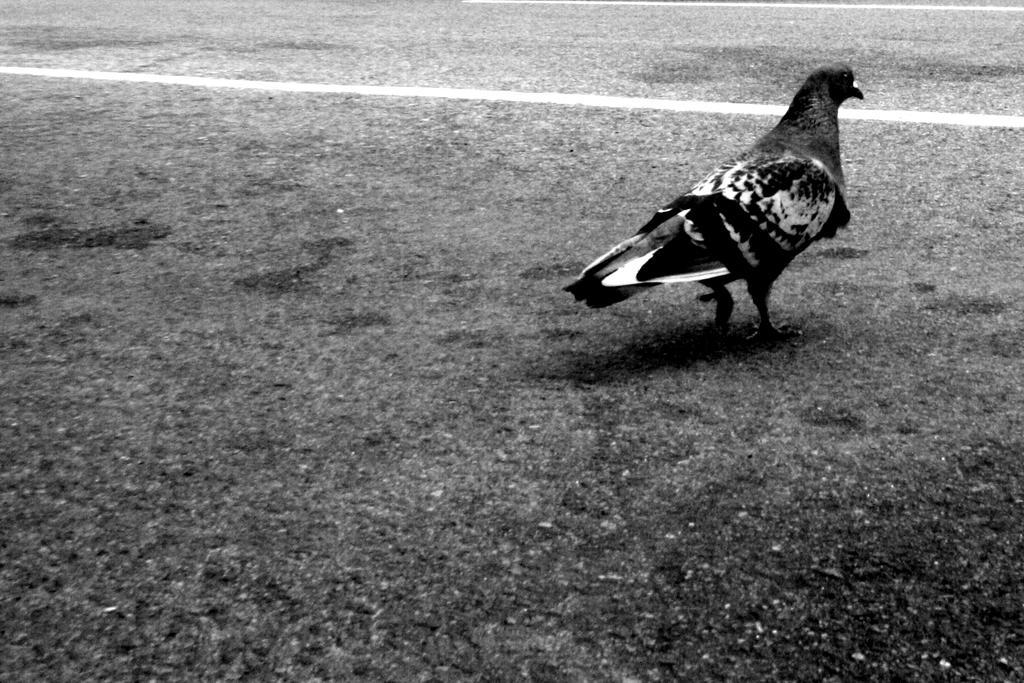In one or two sentences, can you explain what this image depicts? This is a black and white image. There is one dove on the road as we can see on the right side of this image. 